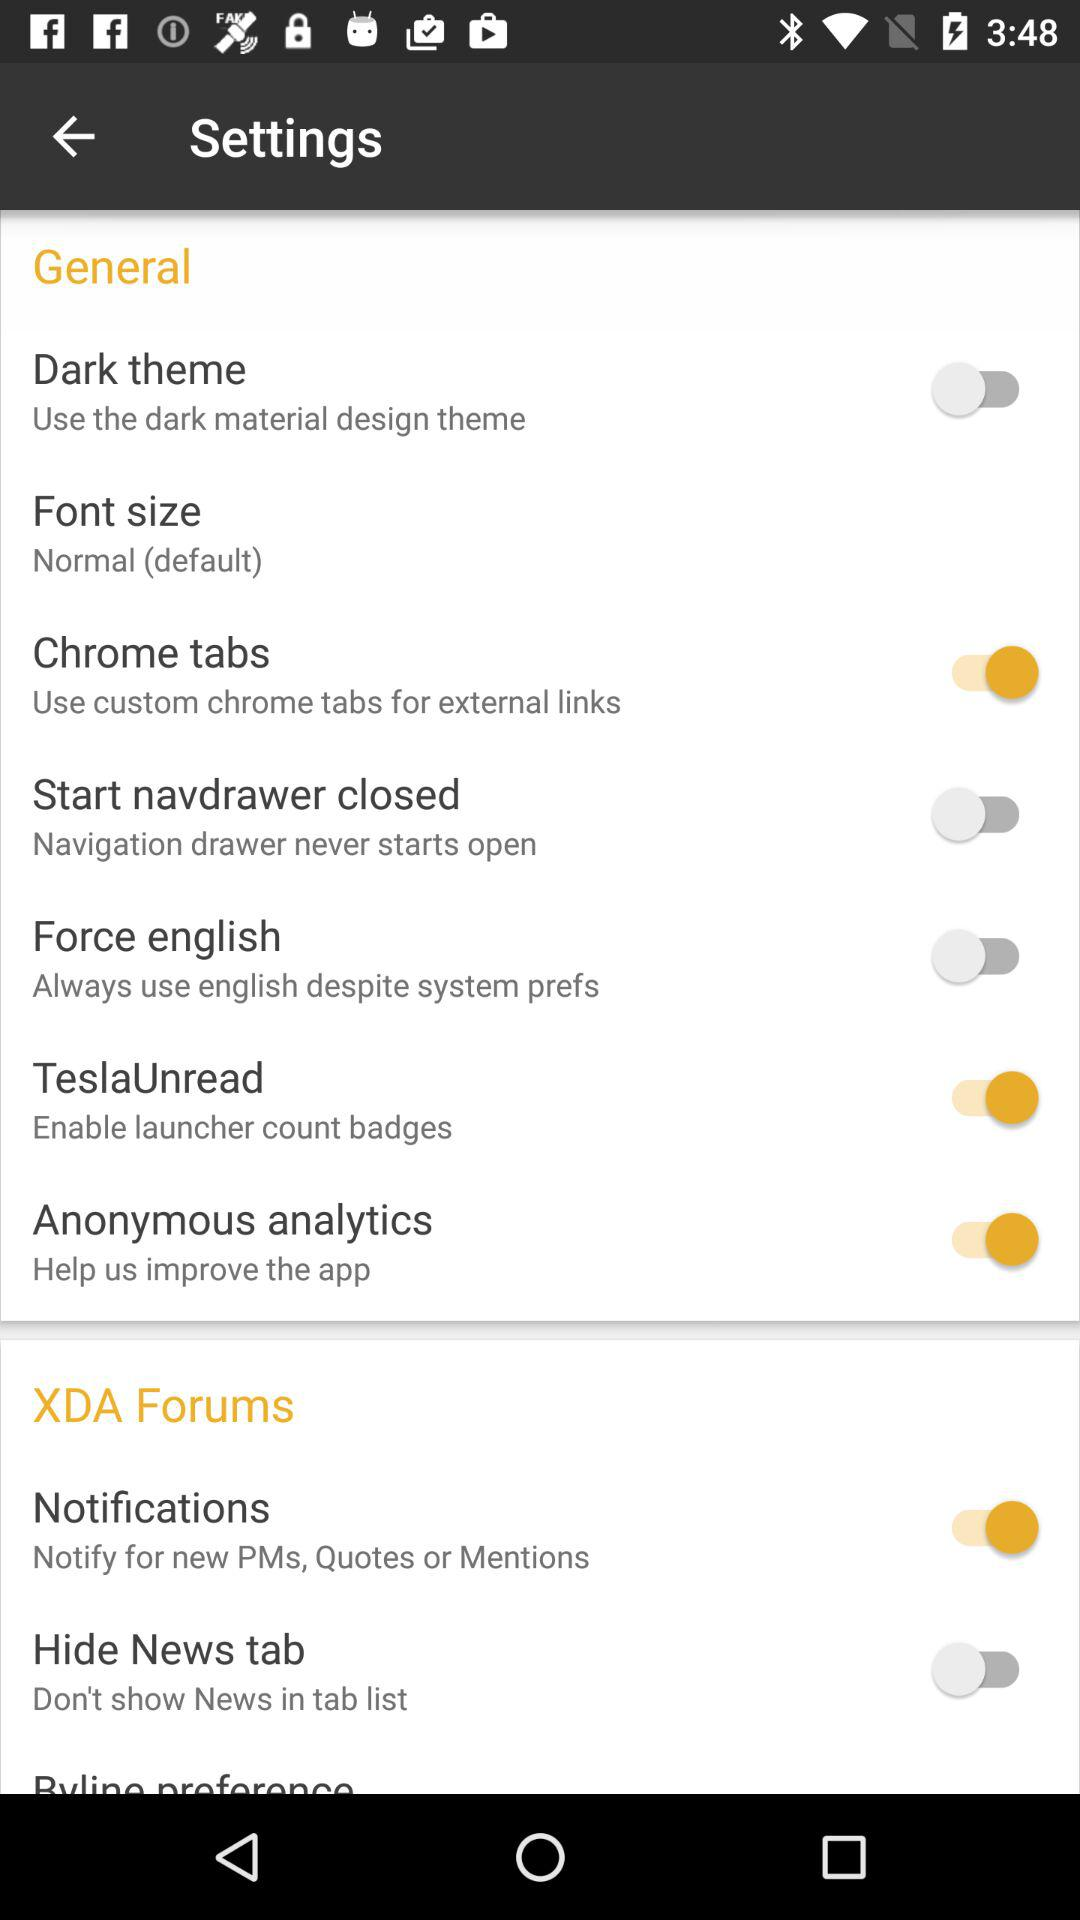What is the status of "Dark theme"? The status of "Dark theme" is "off". 